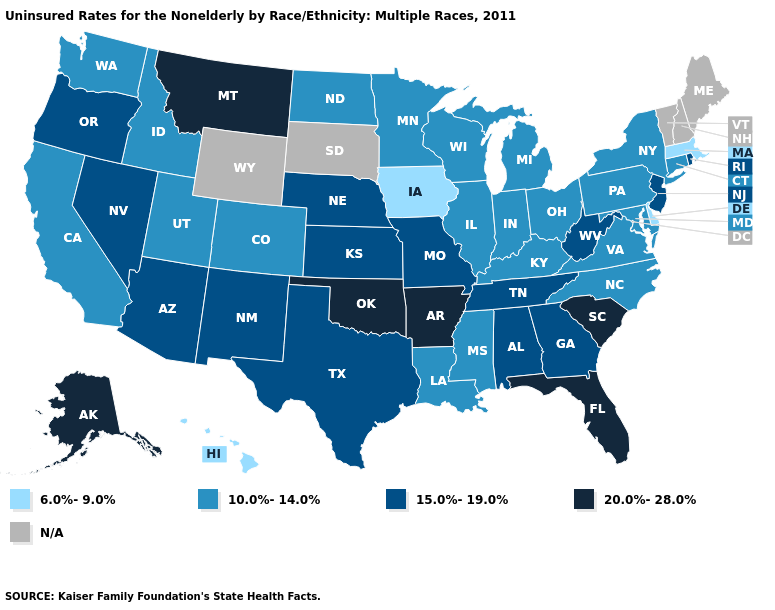What is the value of Virginia?
Concise answer only. 10.0%-14.0%. What is the value of Kentucky?
Write a very short answer. 10.0%-14.0%. Does the map have missing data?
Concise answer only. Yes. Does Rhode Island have the lowest value in the Northeast?
Short answer required. No. What is the value of Arizona?
Give a very brief answer. 15.0%-19.0%. What is the highest value in the West ?
Short answer required. 20.0%-28.0%. Does Delaware have the lowest value in the USA?
Write a very short answer. Yes. Is the legend a continuous bar?
Be succinct. No. Does Massachusetts have the lowest value in the Northeast?
Concise answer only. Yes. Does the map have missing data?
Write a very short answer. Yes. What is the lowest value in states that border Arkansas?
Short answer required. 10.0%-14.0%. Does Massachusetts have the lowest value in the USA?
Short answer required. Yes. Does Massachusetts have the lowest value in the USA?
Quick response, please. Yes. What is the value of New York?
Concise answer only. 10.0%-14.0%. 